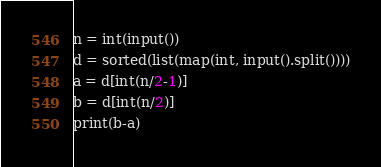<code> <loc_0><loc_0><loc_500><loc_500><_Python_>n = int(input())
d = sorted(list(map(int, input().split())))
a = d[int(n/2-1)]
b = d[int(n/2)]
print(b-a)</code> 